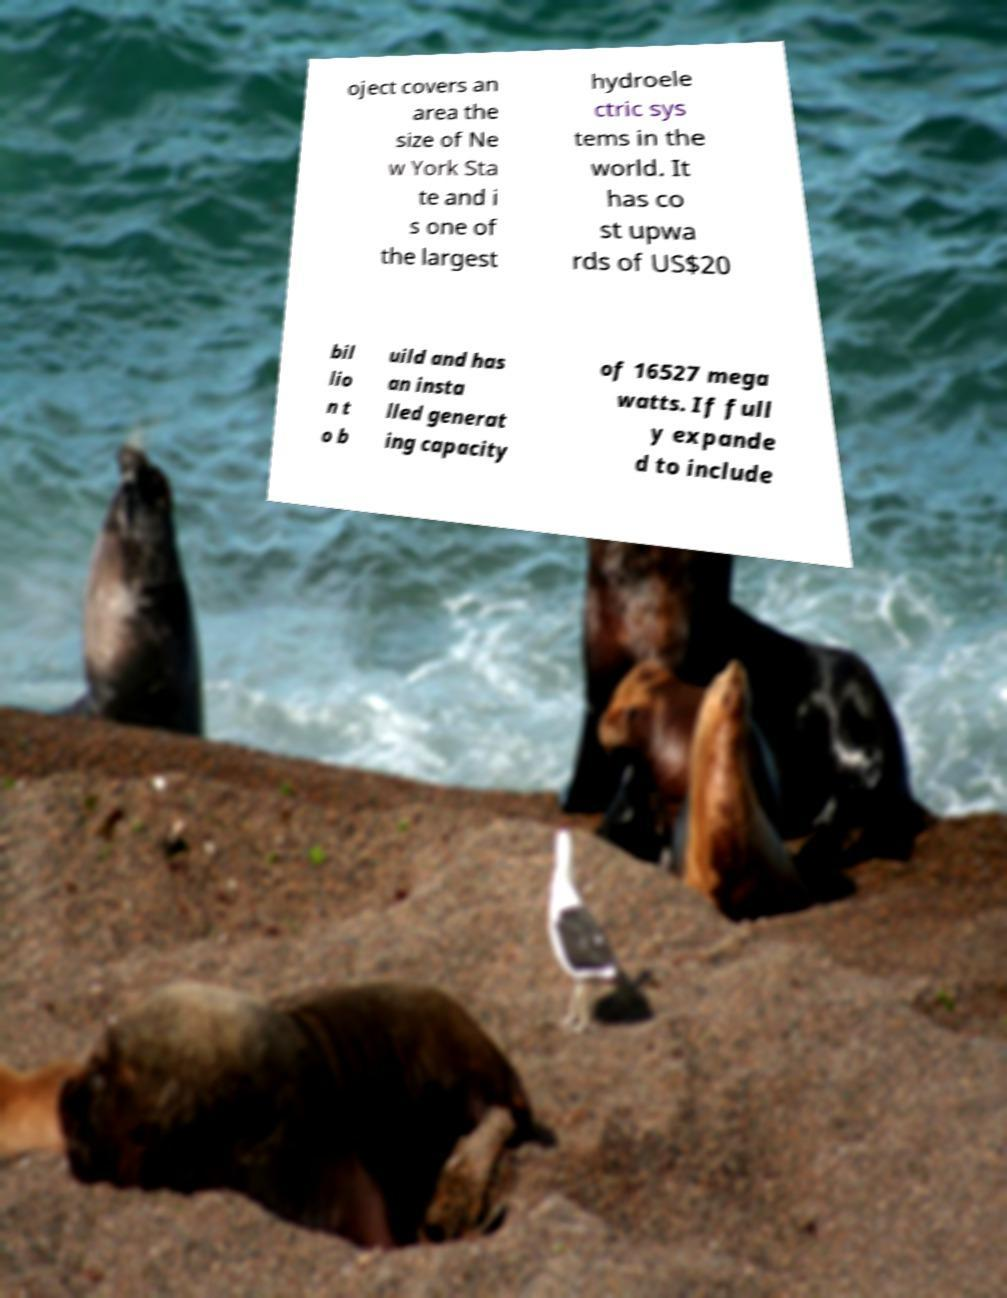I need the written content from this picture converted into text. Can you do that? oject covers an area the size of Ne w York Sta te and i s one of the largest hydroele ctric sys tems in the world. It has co st upwa rds of US$20 bil lio n t o b uild and has an insta lled generat ing capacity of 16527 mega watts. If full y expande d to include 